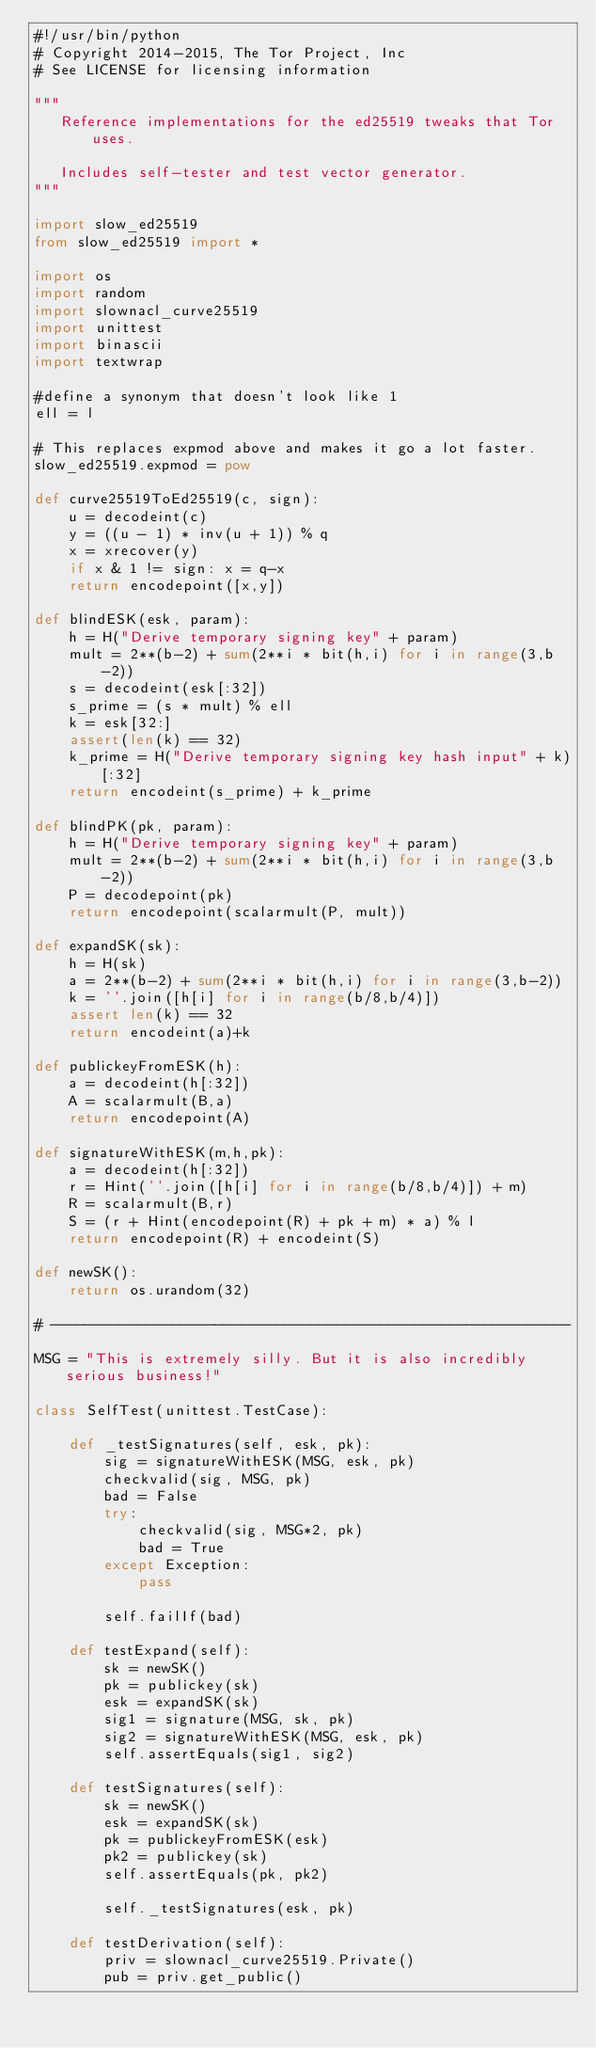<code> <loc_0><loc_0><loc_500><loc_500><_Python_>#!/usr/bin/python
# Copyright 2014-2015, The Tor Project, Inc
# See LICENSE for licensing information

"""
   Reference implementations for the ed25519 tweaks that Tor uses.

   Includes self-tester and test vector generator.
"""

import slow_ed25519
from slow_ed25519 import *

import os
import random
import slownacl_curve25519
import unittest
import binascii
import textwrap

#define a synonym that doesn't look like 1
ell = l

# This replaces expmod above and makes it go a lot faster.
slow_ed25519.expmod = pow

def curve25519ToEd25519(c, sign):
    u = decodeint(c)
    y = ((u - 1) * inv(u + 1)) % q
    x = xrecover(y)
    if x & 1 != sign: x = q-x
    return encodepoint([x,y])

def blindESK(esk, param):
    h = H("Derive temporary signing key" + param)
    mult = 2**(b-2) + sum(2**i * bit(h,i) for i in range(3,b-2))
    s = decodeint(esk[:32])
    s_prime = (s * mult) % ell
    k = esk[32:]
    assert(len(k) == 32)
    k_prime = H("Derive temporary signing key hash input" + k)[:32]
    return encodeint(s_prime) + k_prime

def blindPK(pk, param):
    h = H("Derive temporary signing key" + param)
    mult = 2**(b-2) + sum(2**i * bit(h,i) for i in range(3,b-2))
    P = decodepoint(pk)
    return encodepoint(scalarmult(P, mult))

def expandSK(sk):
    h = H(sk)
    a = 2**(b-2) + sum(2**i * bit(h,i) for i in range(3,b-2))
    k = ''.join([h[i] for i in range(b/8,b/4)])
    assert len(k) == 32
    return encodeint(a)+k

def publickeyFromESK(h):
    a = decodeint(h[:32])
    A = scalarmult(B,a)
    return encodepoint(A)

def signatureWithESK(m,h,pk):
    a = decodeint(h[:32])
    r = Hint(''.join([h[i] for i in range(b/8,b/4)]) + m)
    R = scalarmult(B,r)
    S = (r + Hint(encodepoint(R) + pk + m) * a) % l
    return encodepoint(R) + encodeint(S)

def newSK():
    return os.urandom(32)

# ------------------------------------------------------------

MSG = "This is extremely silly. But it is also incredibly serious business!"

class SelfTest(unittest.TestCase):

    def _testSignatures(self, esk, pk):
        sig = signatureWithESK(MSG, esk, pk)
        checkvalid(sig, MSG, pk)
        bad = False
        try:
            checkvalid(sig, MSG*2, pk)
            bad = True
        except Exception:
            pass

        self.failIf(bad)

    def testExpand(self):
        sk = newSK()
        pk = publickey(sk)
        esk = expandSK(sk)
        sig1 = signature(MSG, sk, pk)
        sig2 = signatureWithESK(MSG, esk, pk)
        self.assertEquals(sig1, sig2)

    def testSignatures(self):
        sk = newSK()
        esk = expandSK(sk)
        pk = publickeyFromESK(esk)
        pk2 = publickey(sk)
        self.assertEquals(pk, pk2)

        self._testSignatures(esk, pk)

    def testDerivation(self):
        priv = slownacl_curve25519.Private()
        pub = priv.get_public()
</code> 